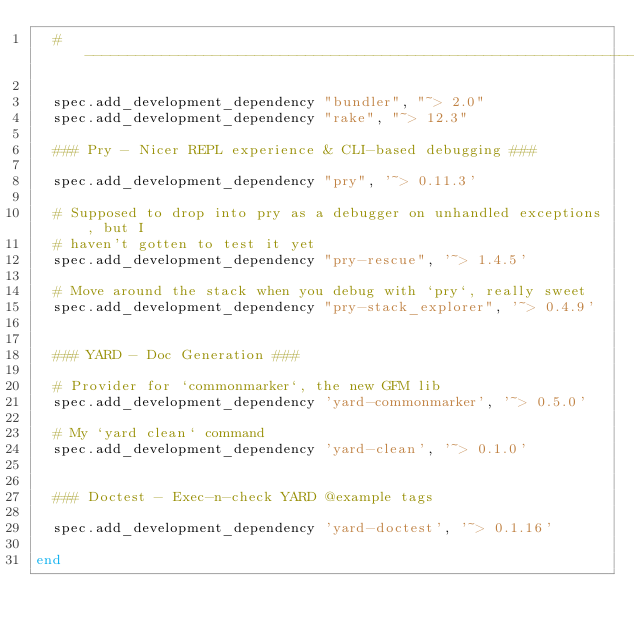Convert code to text. <code><loc_0><loc_0><loc_500><loc_500><_Ruby_>  # ----------------------------------------------------------------------------

  spec.add_development_dependency "bundler", "~> 2.0"
  spec.add_development_dependency "rake", "~> 12.3"
  
  ### Pry - Nicer REPL experience & CLI-based debugging ###
  
  spec.add_development_dependency "pry", '~> 0.11.3'

  # Supposed to drop into pry as a debugger on unhandled exceptions, but I 
  # haven't gotten to test it yet
  spec.add_development_dependency "pry-rescue", '~> 1.4.5'

  # Move around the stack when you debug with `pry`, really sweet
  spec.add_development_dependency "pry-stack_explorer", '~> 0.4.9'
  
  
  ### YARD - Doc Generation ###

  # Provider for `commonmarker`, the new GFM lib
  spec.add_development_dependency 'yard-commonmarker', '~> 0.5.0'
  
  # My `yard clean` command
  spec.add_development_dependency 'yard-clean', '~> 0.1.0'
  
  
  ### Doctest - Exec-n-check YARD @example tags
  
  spec.add_development_dependency 'yard-doctest', '~> 0.1.16'

end
</code> 